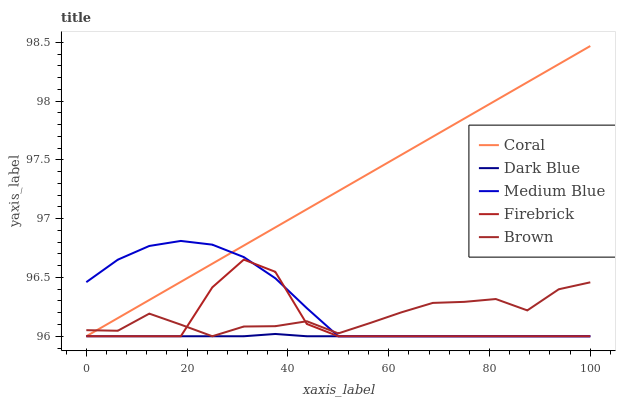Does Dark Blue have the minimum area under the curve?
Answer yes or no. Yes. Does Coral have the maximum area under the curve?
Answer yes or no. Yes. Does Medium Blue have the minimum area under the curve?
Answer yes or no. No. Does Medium Blue have the maximum area under the curve?
Answer yes or no. No. Is Coral the smoothest?
Answer yes or no. Yes. Is Firebrick the roughest?
Answer yes or no. Yes. Is Medium Blue the smoothest?
Answer yes or no. No. Is Medium Blue the roughest?
Answer yes or no. No. Does Dark Blue have the lowest value?
Answer yes or no. Yes. Does Coral have the highest value?
Answer yes or no. Yes. Does Medium Blue have the highest value?
Answer yes or no. No. Does Coral intersect Firebrick?
Answer yes or no. Yes. Is Coral less than Firebrick?
Answer yes or no. No. Is Coral greater than Firebrick?
Answer yes or no. No. 